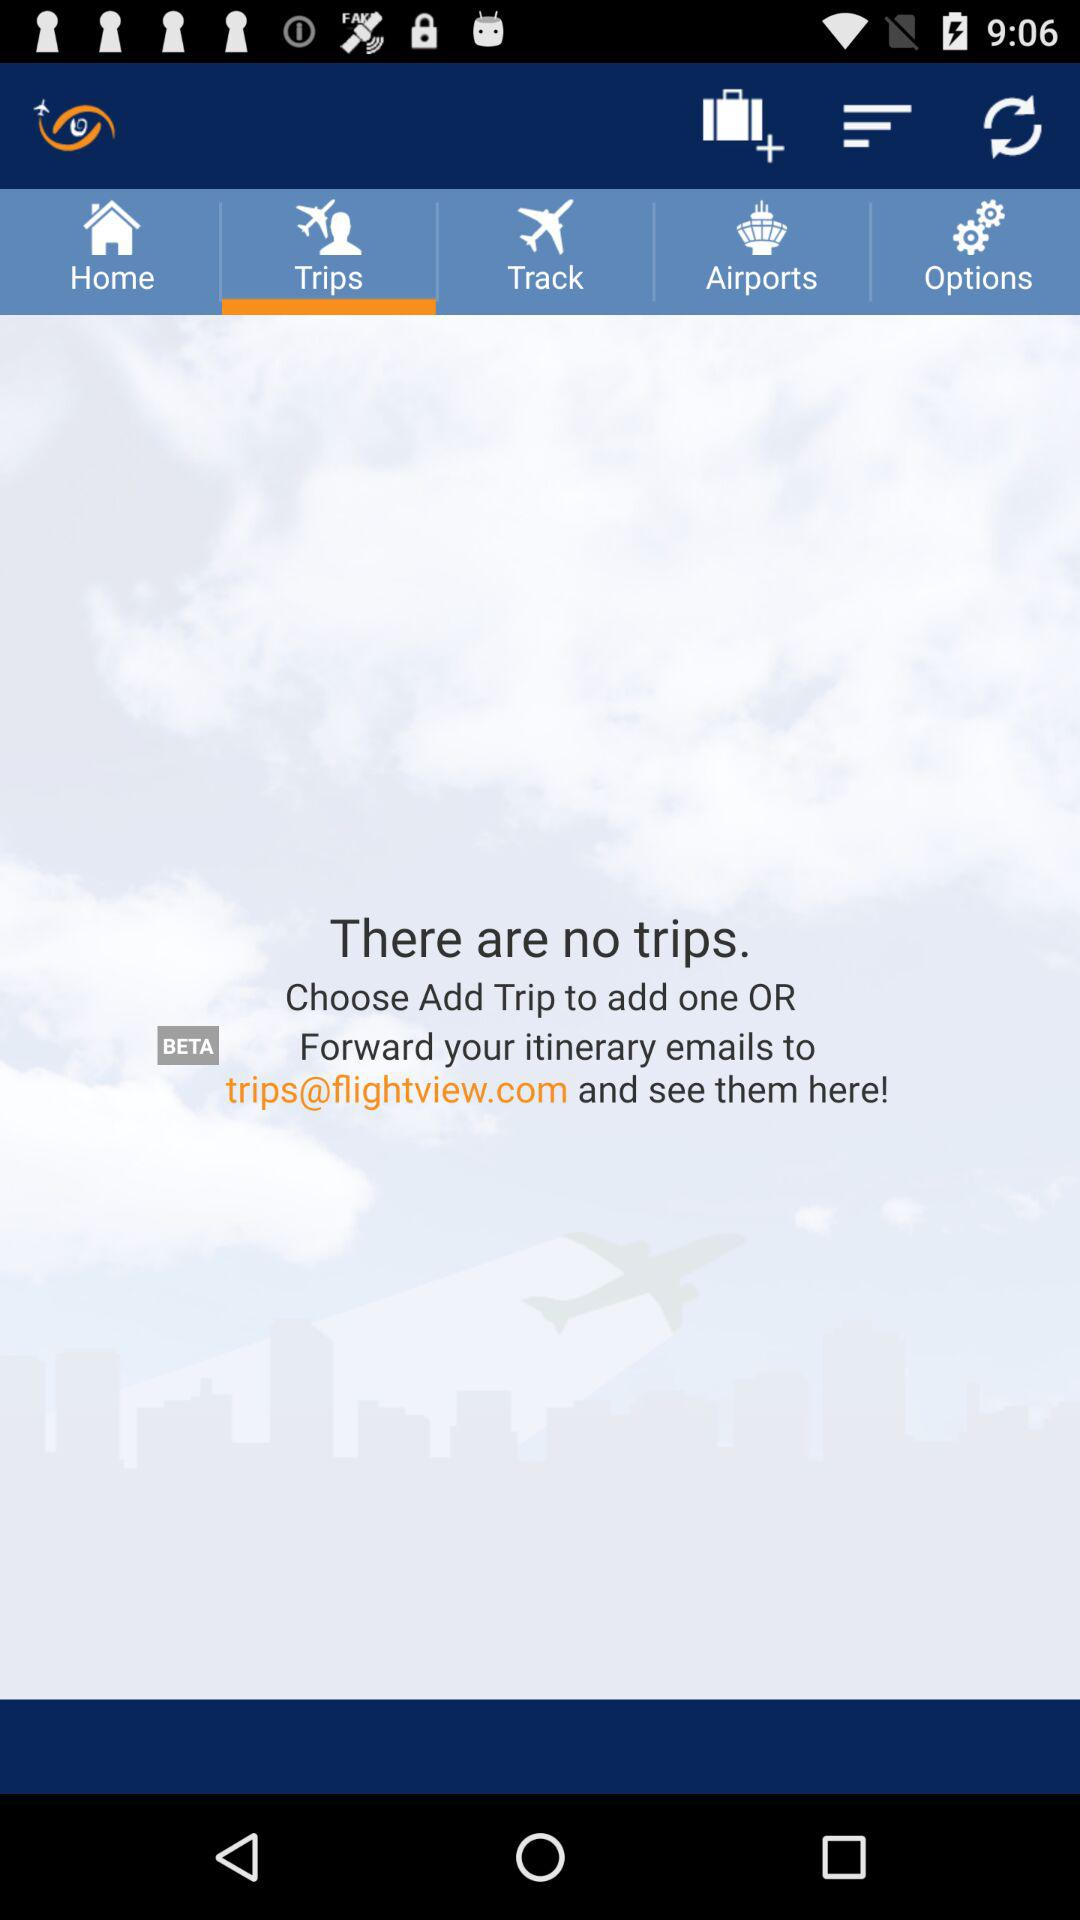Are there any trips available? There are no trips available. 